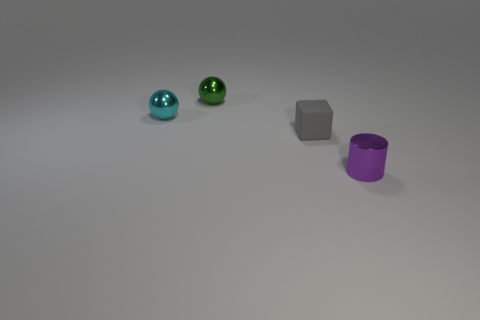Add 1 purple metallic cylinders. How many objects exist? 5 Subtract all cyan cubes. Subtract all green balls. How many cubes are left? 1 Subtract all cubes. How many objects are left? 3 Add 4 purple cylinders. How many purple cylinders are left? 5 Add 1 blue shiny objects. How many blue shiny objects exist? 1 Subtract 1 gray cubes. How many objects are left? 3 Subtract all purple cubes. Subtract all small cyan metallic balls. How many objects are left? 3 